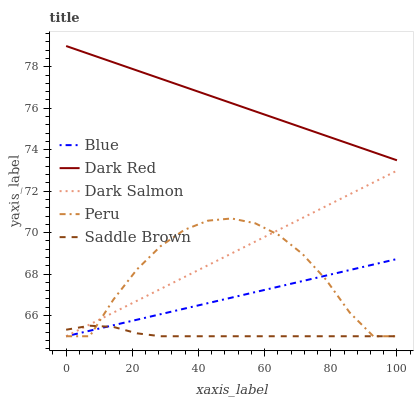Does Saddle Brown have the minimum area under the curve?
Answer yes or no. Yes. Does Dark Red have the maximum area under the curve?
Answer yes or no. Yes. Does Dark Salmon have the minimum area under the curve?
Answer yes or no. No. Does Dark Salmon have the maximum area under the curve?
Answer yes or no. No. Is Blue the smoothest?
Answer yes or no. Yes. Is Peru the roughest?
Answer yes or no. Yes. Is Dark Red the smoothest?
Answer yes or no. No. Is Dark Red the roughest?
Answer yes or no. No. Does Blue have the lowest value?
Answer yes or no. Yes. Does Dark Red have the lowest value?
Answer yes or no. No. Does Dark Red have the highest value?
Answer yes or no. Yes. Does Dark Salmon have the highest value?
Answer yes or no. No. Is Dark Salmon less than Dark Red?
Answer yes or no. Yes. Is Dark Red greater than Peru?
Answer yes or no. Yes. Does Saddle Brown intersect Blue?
Answer yes or no. Yes. Is Saddle Brown less than Blue?
Answer yes or no. No. Is Saddle Brown greater than Blue?
Answer yes or no. No. Does Dark Salmon intersect Dark Red?
Answer yes or no. No. 